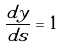Convert formula to latex. <formula><loc_0><loc_0><loc_500><loc_500>\frac { d y } { d s } = 1</formula> 